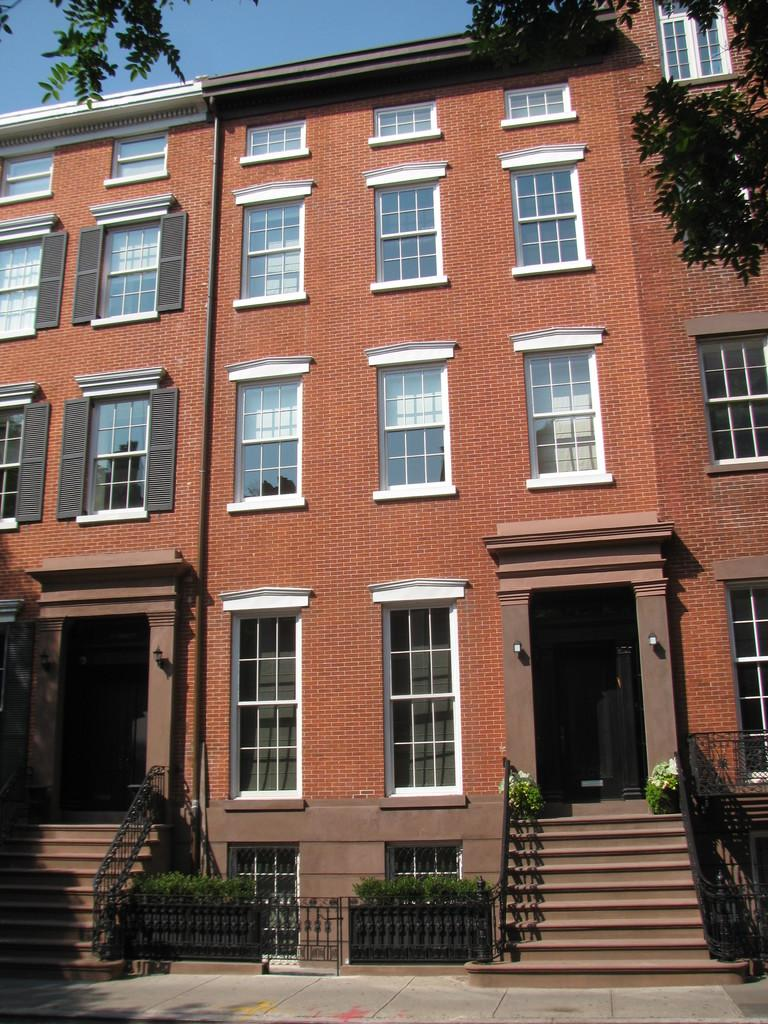What type of structure can be seen in the image? There is a building with windows in the image. What architectural feature is present in the image? There are stairs in the image. What is visible at the top of the image? The sky is visible at the top of the image. Can you see a couple kissing on the stairs in the image? There is no couple kissing on the stairs in the image. What type of weather condition is present in the image, such as fog? There is no mention of fog or any specific weather condition in the image; only the sky is visible. 